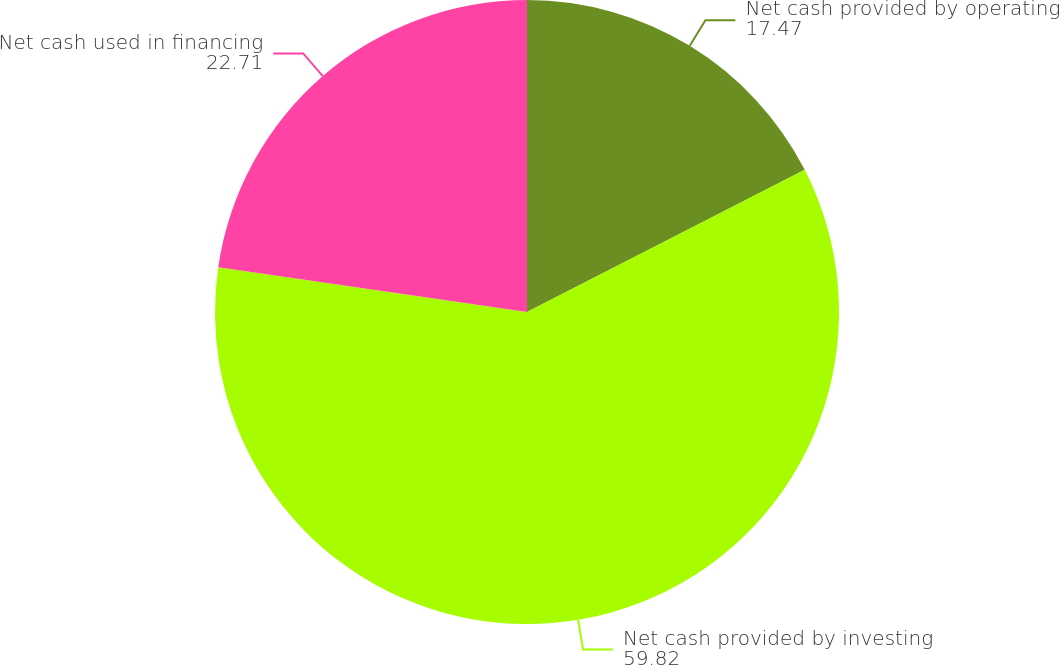Convert chart to OTSL. <chart><loc_0><loc_0><loc_500><loc_500><pie_chart><fcel>Net cash provided by operating<fcel>Net cash provided by investing<fcel>Net cash used in financing<nl><fcel>17.47%<fcel>59.82%<fcel>22.71%<nl></chart> 